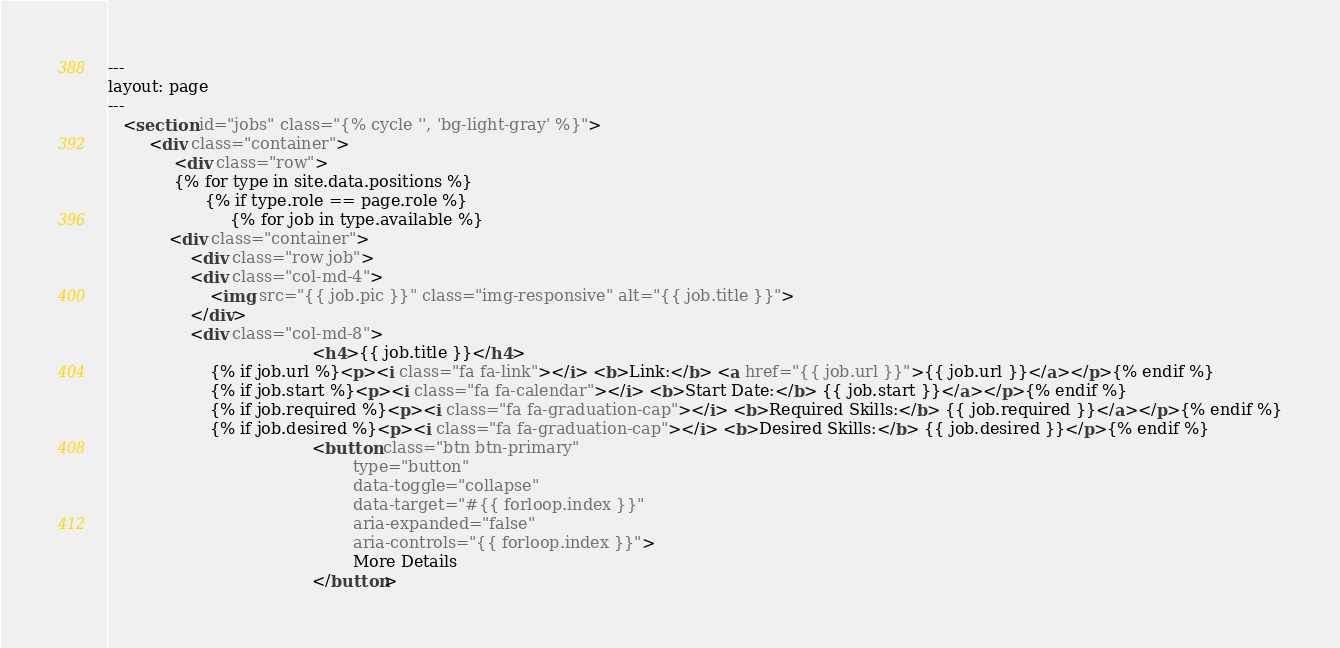<code> <loc_0><loc_0><loc_500><loc_500><_HTML_>---
layout: page 
---
   <section id="jobs" class="{% cycle '', 'bg-light-gray' %}">
        <div class="container">
             <div class="row">
             {% for type in site.data.positions %}
                   {% if type.role == page.role %}
                        {% for job in type.available %}
			<div class="container">
			    <div class="row job">
				<div class="col-md-4">
					<img src="{{ job.pic }}" class="img-responsive" alt="{{ job.title }}">
				</div>
				<div class="col-md-8"> 
                                        <h4>{{ job.title }}</h4> 
					{% if job.url %}<p><i class="fa fa-link"></i> <b>Link:</b> <a href="{{ job.url }}">{{ job.url }}</a></p>{% endif %}
					{% if job.start %}<p><i class="fa fa-calendar"></i> <b>Start Date:</b> {{ job.start }}</a></p>{% endif %}
					{% if job.required %}<p><i class="fa fa-graduation-cap"></i> <b>Required Skills:</b> {{ job.required }}</a></p>{% endif %}
					{% if job.desired %}<p><i class="fa fa-graduation-cap"></i> <b>Desired Skills:</b> {{ job.desired }}</p>{% endif %}
                                        <button class="btn btn-primary" 
                                                type="button" 
                                                data-toggle="collapse" 
                                                data-target="#{{ forloop.index }}" 
                                                aria-expanded="false" 
                                                aria-controls="{{ forloop.index }}">
                                                More Details 
                                        </button> </code> 